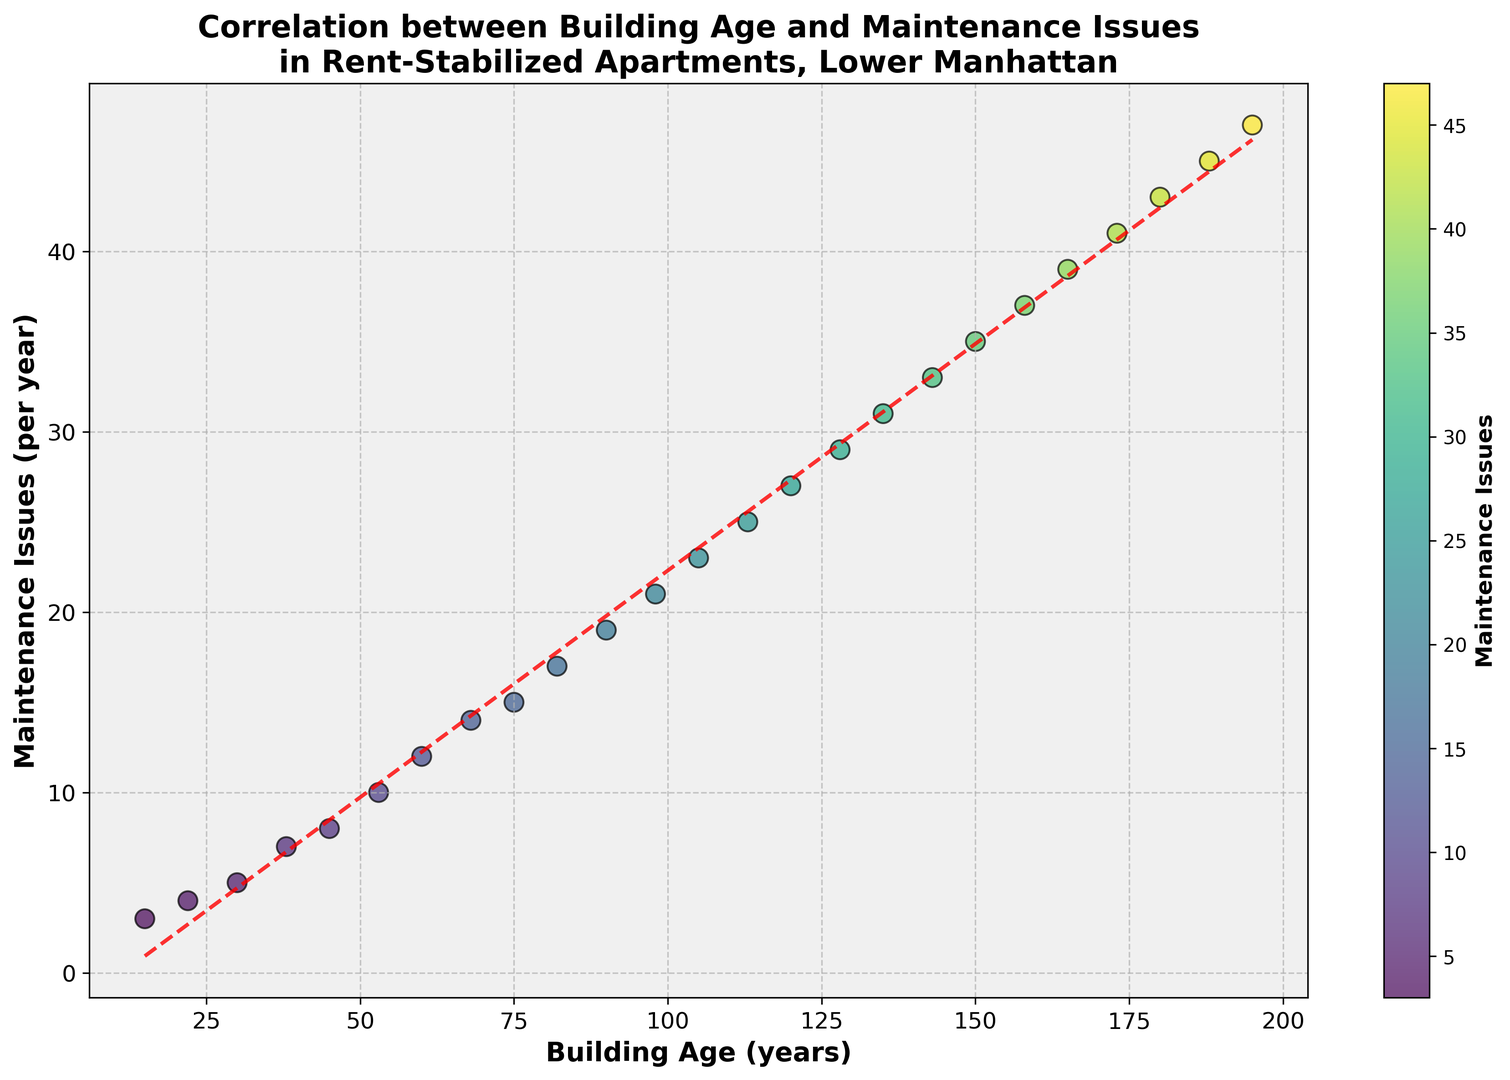What is the trendline showing about the relationship between building age and maintenance issues? The trendline is a red dashed line fitted to the data points. It visually demonstrates a positive correlation between building age and maintenance issues, indicating that as buildings get older, the number of maintenance issues increases.
Answer: Positive correlation What color is used for higher numbers of maintenance issues in the scatter plot? Higher numbers of maintenance issues are represented by points colored towards the yellow end of the viridis color map. This is seen on the color bar next to the scatter plot.
Answer: Yellow Which building age has the smallest number of maintenance issues, and what is the corresponding value? The smallest number of maintenance issues is at the youngest building age of 15 years, with 3 maintenance issues per year. This is seen from the point closest to the origin on the x-axis.
Answer: 15 years, 3 issues How do the buildings aged 75 and 150 years old compare in terms of maintenance issues? Buildings aged 75 years have 15 maintenance issues, while buildings aged 150 years have 35. Comparing these, the 150-year-old buildings have 20 more maintenance issues than the 75-year-old buildings.
Answer: 150-year-old buildings have 20 more issues Based on the scatter plot, estimate the number of maintenance issues for a building age of 100 years. Considering the trendline, for a building age of around 100 years, the number of maintenance issues is approximately 22. This estimate is based on the position of data points and the red dashed trendline near the 100-year mark.
Answer: Approximately 22 issues What is the average increase in maintenance issues per year based on the trendline equation? The trendline equation can be extracted using the displayed data points and their fitted line. The slope of the trendline indicates this average yearly increase, which appears to be approximately (47-3)/(195-15) = 44/180 ≈ 0.24 maintenance issues per year.
Answer: Approximately 0.24 issues/year Do any buildings deviate significantly from the trendline, and which ones are they? Most of the points are close to the trendline, but the point at 195 years with 47 maintenance issues is slightly higher than expected. This is identified by observing it above the trendline.
Answer: 195-year-old building with 47 issues How many maintenance issues would a building have if it were 50 years old according to the trendline? Using the trendline equation, substitute x = 50 into the trendline equation (y = 0.24x + 1.5). Plugging these values gives y ≈ 0.24 * 50 + 1.5 ≈ 13.5 issues per year.
Answer: Approximately 13.5 issues What is the difference in maintenance issues between the oldest and youngest buildings? The oldest buildings are 195 years old with 47 maintenance issues, and the youngest buildings are 15 years old with 3 maintenance issues. The difference is 47 - 3 = 44 maintenance issues.
Answer: 44 issues 